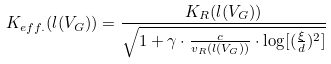<formula> <loc_0><loc_0><loc_500><loc_500>K _ { e f f . } ( l ( V _ { G } ) ) = \frac { K _ { R } ( l ( V _ { G } ) ) } { \sqrt { 1 + \gamma \cdot \frac { c } { v _ { R } ( l ( V _ { G } ) ) } \cdot \log [ ( \frac { \xi } { d } ) ^ { 2 } ] } }</formula> 